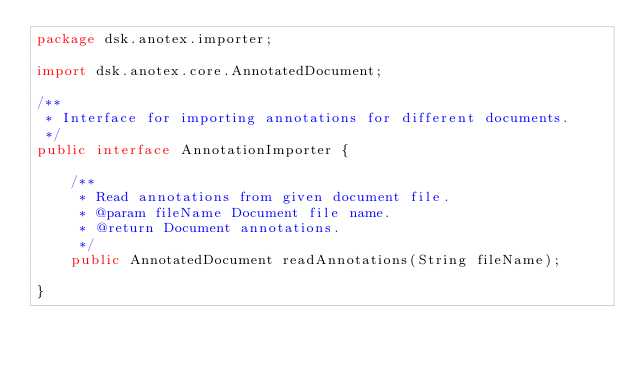Convert code to text. <code><loc_0><loc_0><loc_500><loc_500><_Java_>package dsk.anotex.importer;

import dsk.anotex.core.AnnotatedDocument;

/**
 * Interface for importing annotations for different documents.
 */
public interface AnnotationImporter {

    /**
     * Read annotations from given document file.
     * @param fileName Document file name.
     * @return Document annotations.
     */
    public AnnotatedDocument readAnnotations(String fileName);

}
</code> 